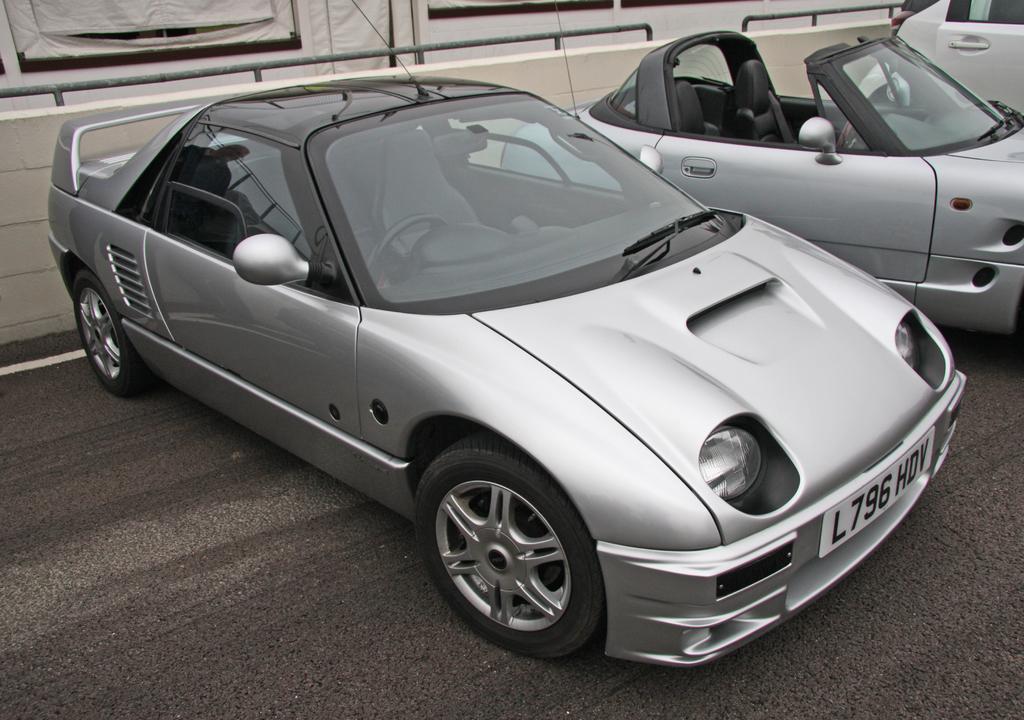Please provide a concise description of this image. In the picture we can see three cars which are parked on the path near the wall and they are gray in color which some black color part of it. 